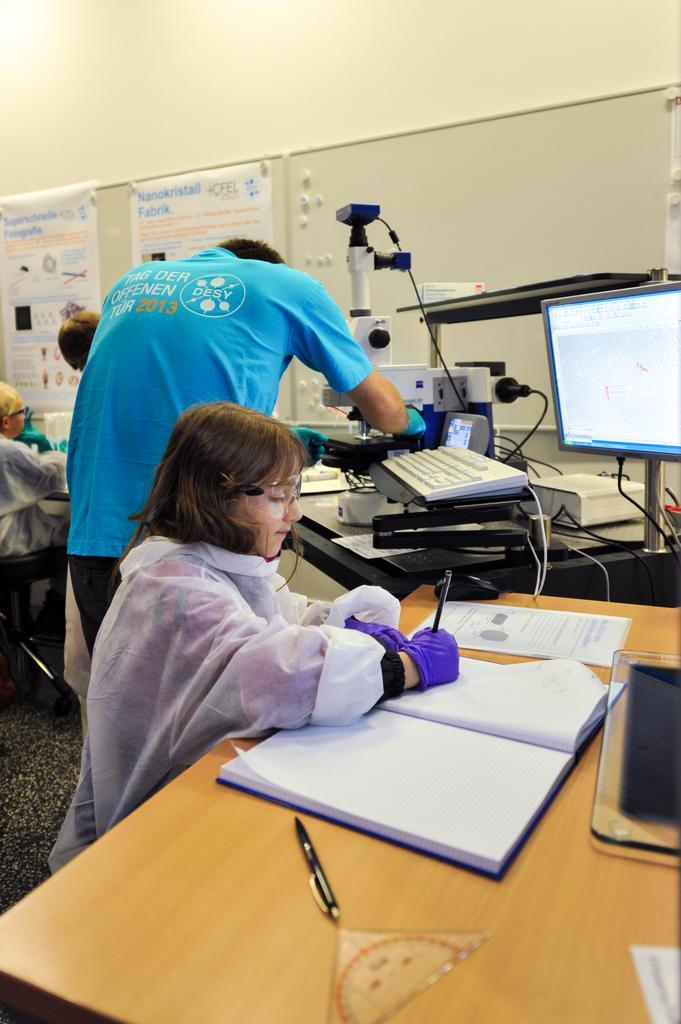How would you summarize this image in a sentence or two? This image is Clicked in a lab. There is a table on the right side on that table there is a book ,pen ,papers. There is a girl sitting near this table in front of her there is a system which is on the right side there are lab equipments. There are two posters placed on the left side. There is a person sitting on the left side. 